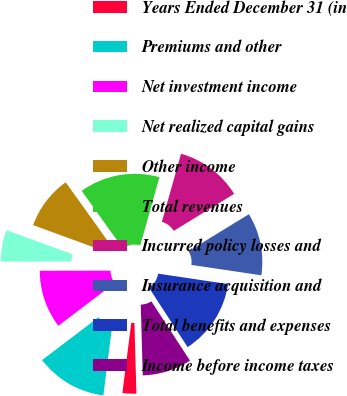Convert chart. <chart><loc_0><loc_0><loc_500><loc_500><pie_chart><fcel>Years Ended December 31 (in<fcel>Premiums and other<fcel>Net investment income<fcel>Net realized capital gains<fcel>Other income<fcel>Total revenues<fcel>Incurred policy losses and<fcel>Insurance acquisition and<fcel>Total benefits and expenses<fcel>Income before income taxes<nl><fcel>2.45%<fcel>12.67%<fcel>10.31%<fcel>5.6%<fcel>9.53%<fcel>14.25%<fcel>11.89%<fcel>11.1%<fcel>13.46%<fcel>8.74%<nl></chart> 